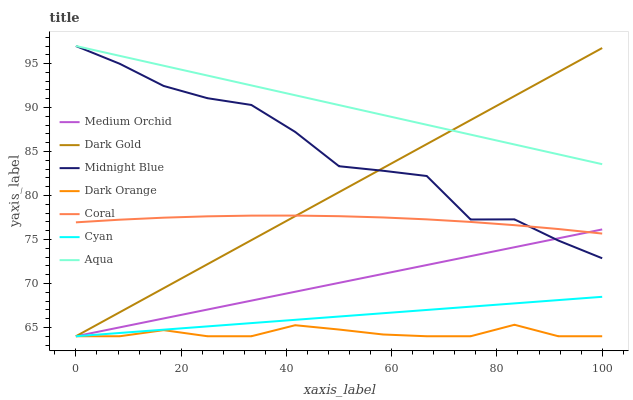Does Dark Orange have the minimum area under the curve?
Answer yes or no. Yes. Does Aqua have the maximum area under the curve?
Answer yes or no. Yes. Does Midnight Blue have the minimum area under the curve?
Answer yes or no. No. Does Midnight Blue have the maximum area under the curve?
Answer yes or no. No. Is Cyan the smoothest?
Answer yes or no. Yes. Is Midnight Blue the roughest?
Answer yes or no. Yes. Is Dark Gold the smoothest?
Answer yes or no. No. Is Dark Gold the roughest?
Answer yes or no. No. Does Dark Orange have the lowest value?
Answer yes or no. Yes. Does Midnight Blue have the lowest value?
Answer yes or no. No. Does Aqua have the highest value?
Answer yes or no. Yes. Does Dark Gold have the highest value?
Answer yes or no. No. Is Cyan less than Midnight Blue?
Answer yes or no. Yes. Is Midnight Blue greater than Cyan?
Answer yes or no. Yes. Does Midnight Blue intersect Aqua?
Answer yes or no. Yes. Is Midnight Blue less than Aqua?
Answer yes or no. No. Is Midnight Blue greater than Aqua?
Answer yes or no. No. Does Cyan intersect Midnight Blue?
Answer yes or no. No. 